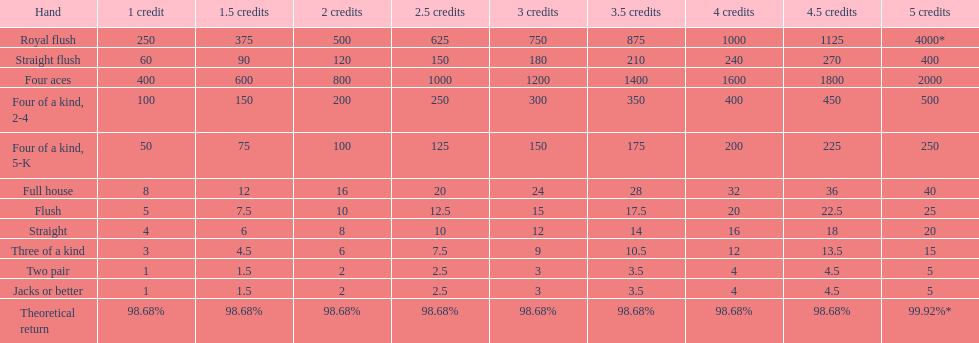After winning on four credits with a full house, what is your payout? 32. 